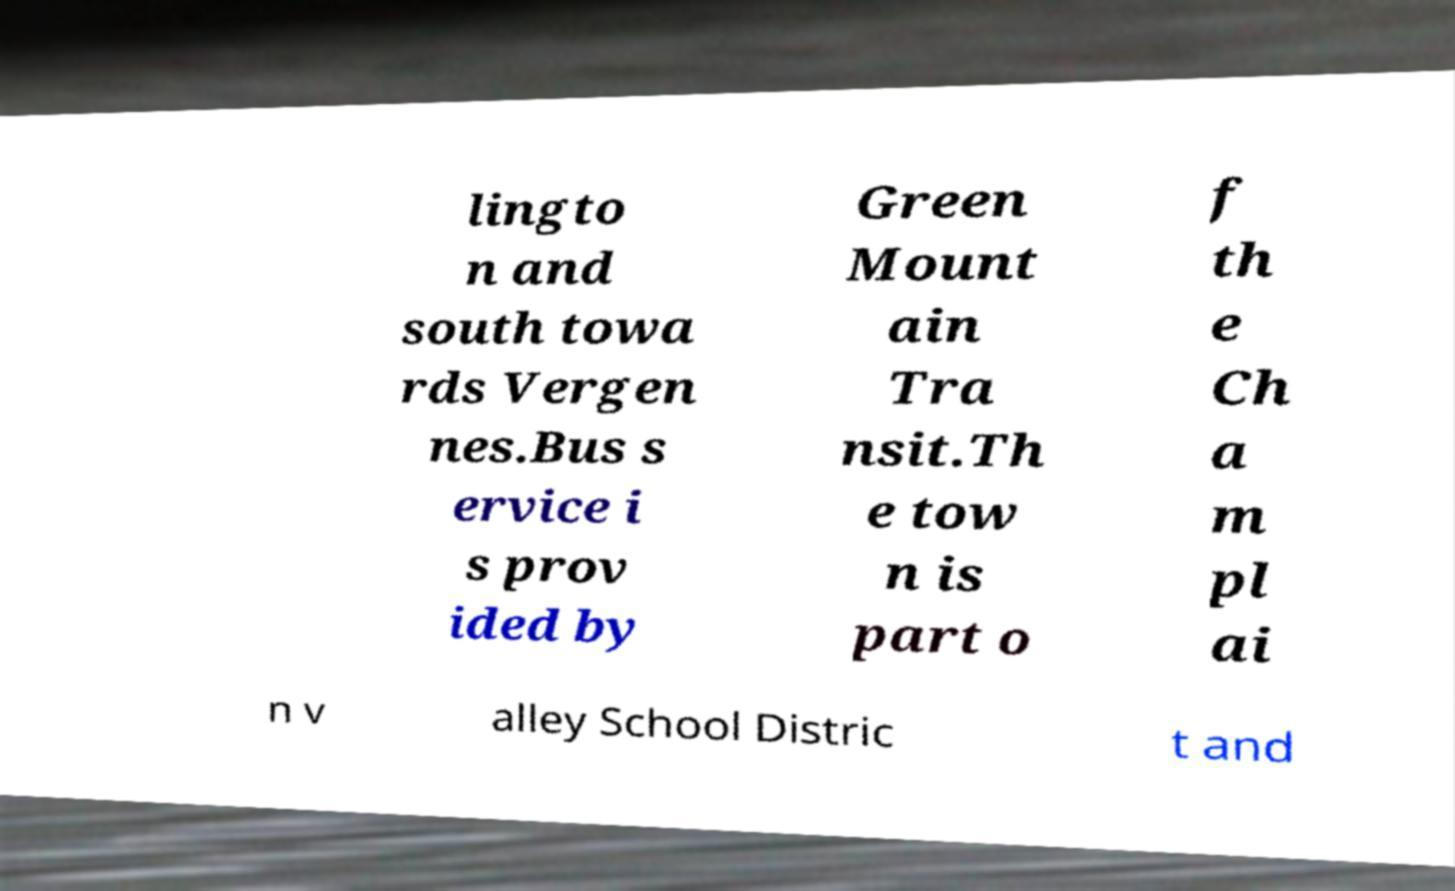Could you extract and type out the text from this image? lingto n and south towa rds Vergen nes.Bus s ervice i s prov ided by Green Mount ain Tra nsit.Th e tow n is part o f th e Ch a m pl ai n v alley School Distric t and 